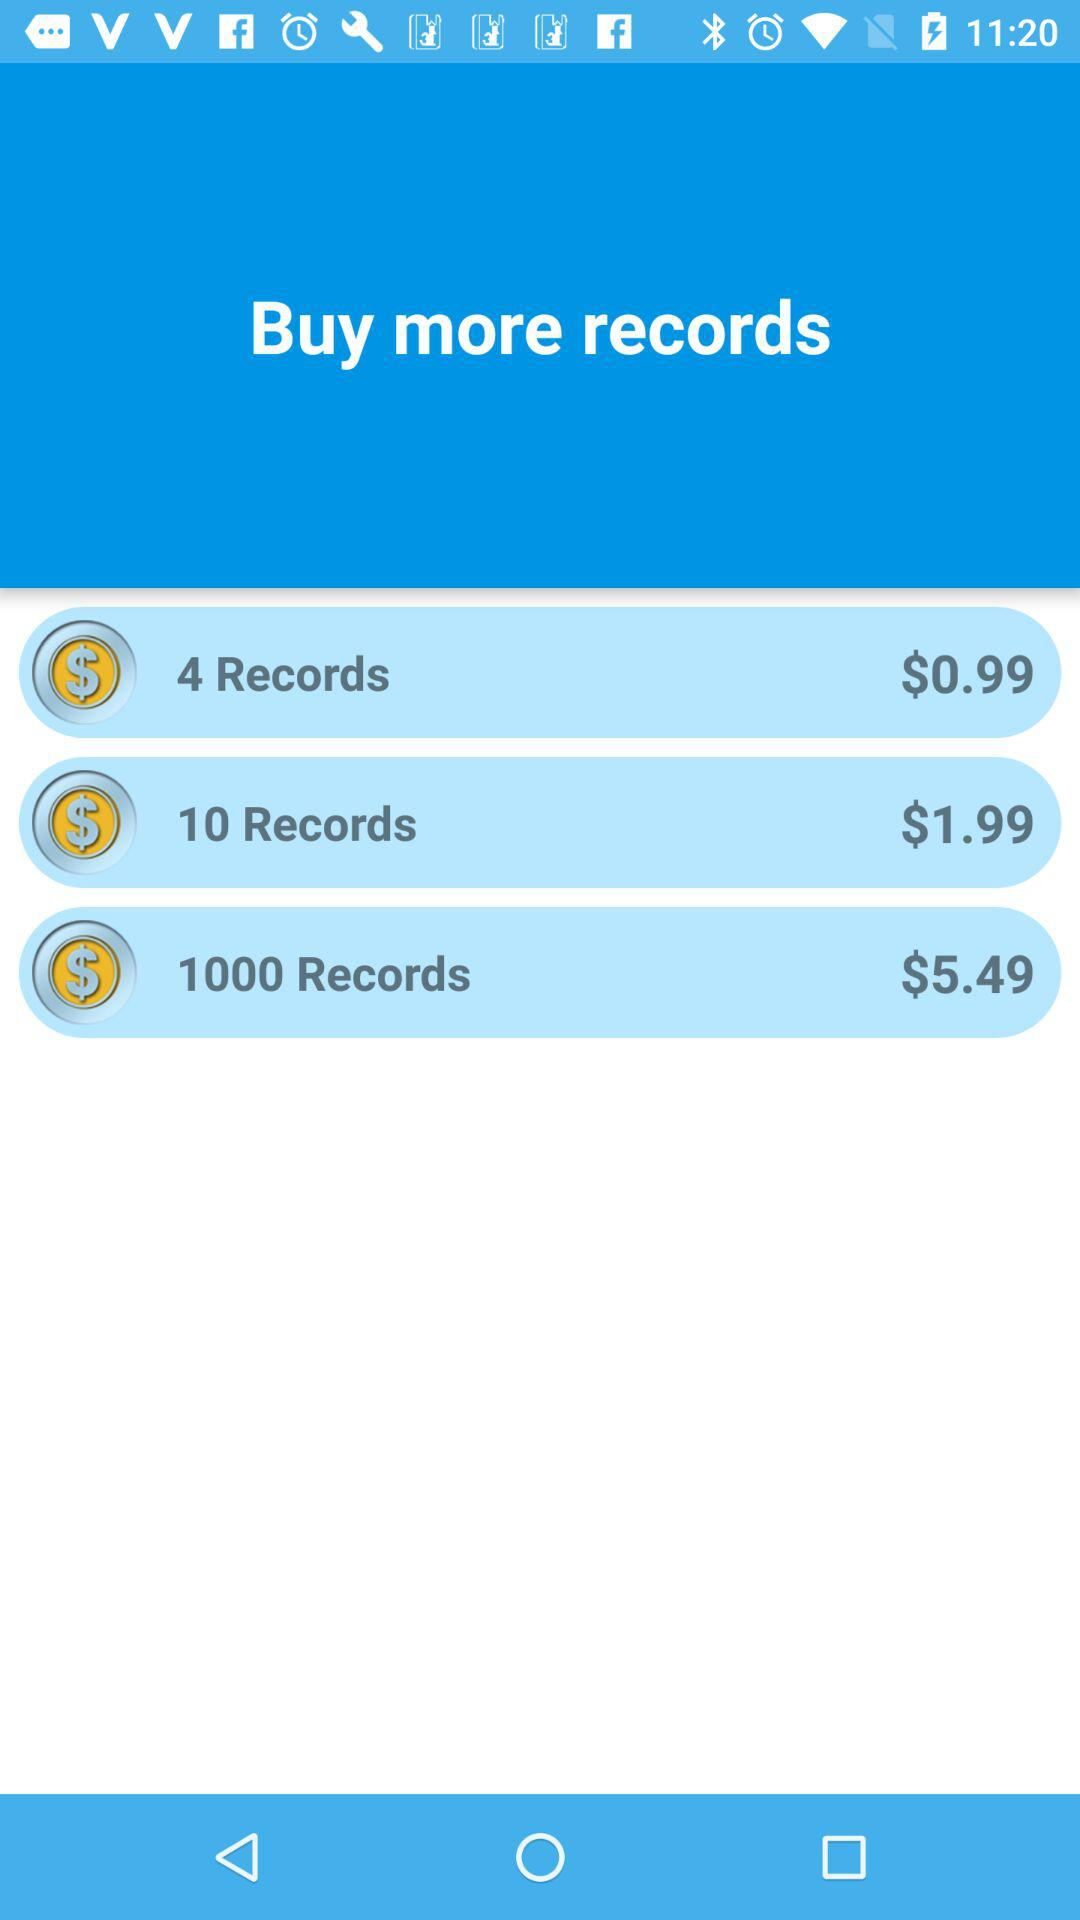How many records can be bought at $0.99? You can buy 4 records. 